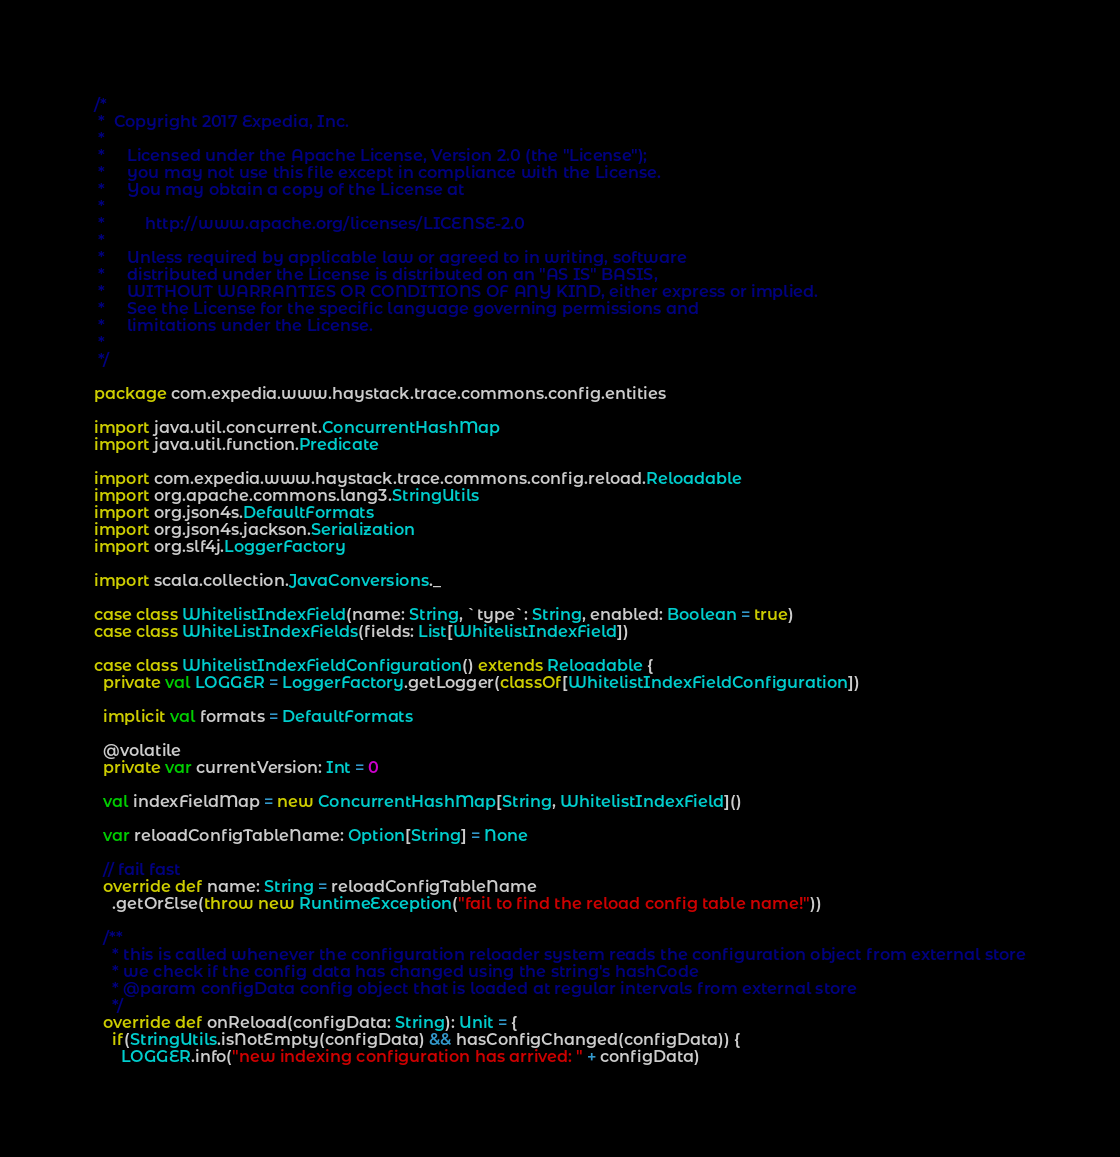Convert code to text. <code><loc_0><loc_0><loc_500><loc_500><_Scala_>/*
 *  Copyright 2017 Expedia, Inc.
 *
 *     Licensed under the Apache License, Version 2.0 (the "License");
 *     you may not use this file except in compliance with the License.
 *     You may obtain a copy of the License at
 *
 *         http://www.apache.org/licenses/LICENSE-2.0
 *
 *     Unless required by applicable law or agreed to in writing, software
 *     distributed under the License is distributed on an "AS IS" BASIS,
 *     WITHOUT WARRANTIES OR CONDITIONS OF ANY KIND, either express or implied.
 *     See the License for the specific language governing permissions and
 *     limitations under the License.
 *
 */

package com.expedia.www.haystack.trace.commons.config.entities

import java.util.concurrent.ConcurrentHashMap
import java.util.function.Predicate

import com.expedia.www.haystack.trace.commons.config.reload.Reloadable
import org.apache.commons.lang3.StringUtils
import org.json4s.DefaultFormats
import org.json4s.jackson.Serialization
import org.slf4j.LoggerFactory

import scala.collection.JavaConversions._

case class WhitelistIndexField(name: String, `type`: String, enabled: Boolean = true)
case class WhiteListIndexFields(fields: List[WhitelistIndexField])

case class WhitelistIndexFieldConfiguration() extends Reloadable {
  private val LOGGER = LoggerFactory.getLogger(classOf[WhitelistIndexFieldConfiguration])

  implicit val formats = DefaultFormats

  @volatile
  private var currentVersion: Int = 0

  val indexFieldMap = new ConcurrentHashMap[String, WhitelistIndexField]()

  var reloadConfigTableName: Option[String] = None

  // fail fast
  override def name: String = reloadConfigTableName
    .getOrElse(throw new RuntimeException("fail to find the reload config table name!"))

  /**
    * this is called whenever the configuration reloader system reads the configuration object from external store
    * we check if the config data has changed using the string's hashCode
    * @param configData config object that is loaded at regular intervals from external store
    */
  override def onReload(configData: String): Unit = {
    if(StringUtils.isNotEmpty(configData) && hasConfigChanged(configData)) {
      LOGGER.info("new indexing configuration has arrived: " + configData)</code> 